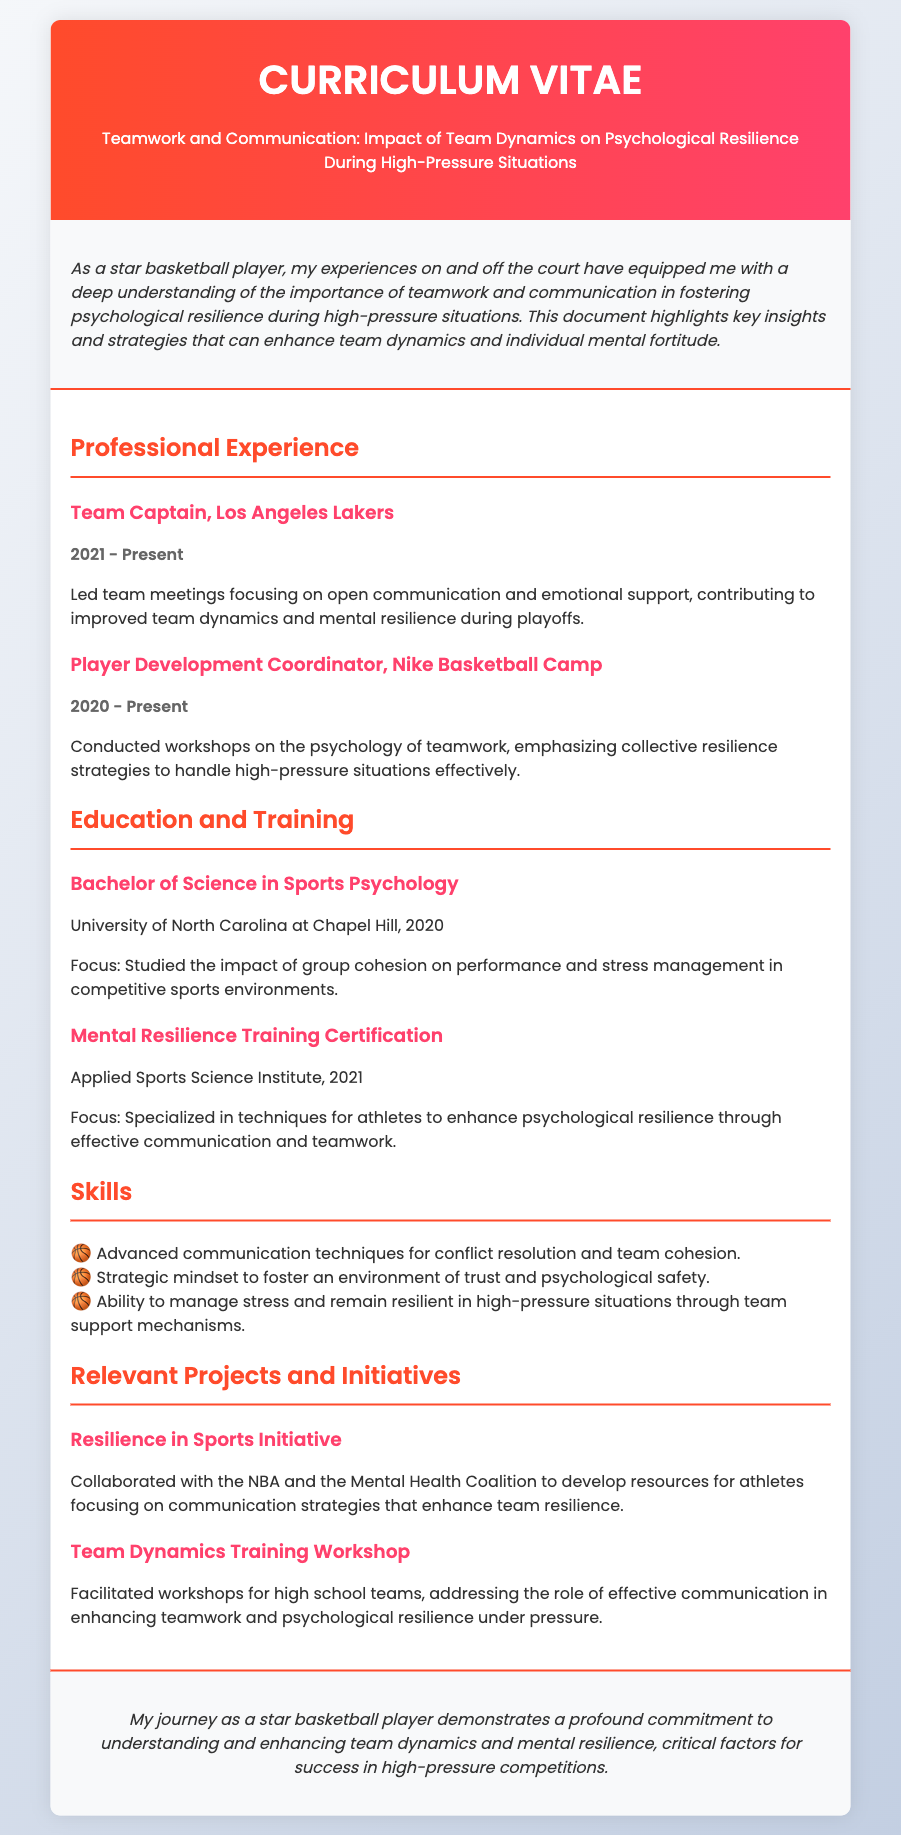What is the title of the CV? The title of the CV is provided in the header section of the document.
Answer: Teamwork and Communication: Impact of Team Dynamics on Psychological Resilience During High-Pressure Situations Who is the current team captain? The document specifies the current position held by the individual.
Answer: Team Captain, Los Angeles Lakers When did the player start working with Nike Basketball Camp? The duration of the player's role at Nike Basketball Camp is mentioned in the experience section.
Answer: 2020 What degree did the player obtain? The document lists the player's educational qualifications, including their degree.
Answer: Bachelor of Science in Sports Psychology What is a skill mentioned related to teamwork? The skills section outlines several skills related to teamwork and communication.
Answer: Advanced communication techniques for conflict resolution and team cohesion Which initiative was developed in collaboration with the NBA? The relevant projects section mentions initiatives the player worked on.
Answer: Resilience in Sports Initiative What is the focus of the Mental Resilience Training Certification? The focus of the certification is detailed in the education section of the CV.
Answer: Specialized in techniques for athletes to enhance psychological resilience through effective communication and teamwork In what year did the player complete their degree? The document provides the graduation year for the player's degree.
Answer: 2020 What is the player's role in the Team Dynamics Training Workshop? The document describes the function the player had in this workshop.
Answer: Facilitated workshops for high school teams 